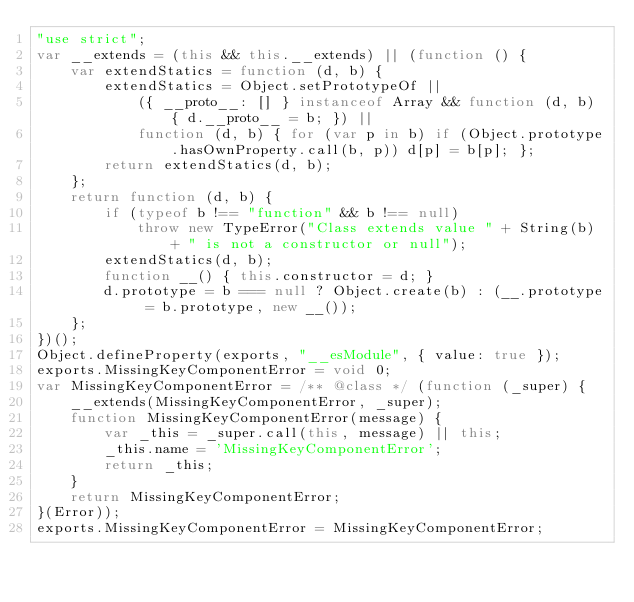<code> <loc_0><loc_0><loc_500><loc_500><_JavaScript_>"use strict";
var __extends = (this && this.__extends) || (function () {
    var extendStatics = function (d, b) {
        extendStatics = Object.setPrototypeOf ||
            ({ __proto__: [] } instanceof Array && function (d, b) { d.__proto__ = b; }) ||
            function (d, b) { for (var p in b) if (Object.prototype.hasOwnProperty.call(b, p)) d[p] = b[p]; };
        return extendStatics(d, b);
    };
    return function (d, b) {
        if (typeof b !== "function" && b !== null)
            throw new TypeError("Class extends value " + String(b) + " is not a constructor or null");
        extendStatics(d, b);
        function __() { this.constructor = d; }
        d.prototype = b === null ? Object.create(b) : (__.prototype = b.prototype, new __());
    };
})();
Object.defineProperty(exports, "__esModule", { value: true });
exports.MissingKeyComponentError = void 0;
var MissingKeyComponentError = /** @class */ (function (_super) {
    __extends(MissingKeyComponentError, _super);
    function MissingKeyComponentError(message) {
        var _this = _super.call(this, message) || this;
        _this.name = 'MissingKeyComponentError';
        return _this;
    }
    return MissingKeyComponentError;
}(Error));
exports.MissingKeyComponentError = MissingKeyComponentError;
</code> 